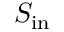<formula> <loc_0><loc_0><loc_500><loc_500>S _ { i n }</formula> 